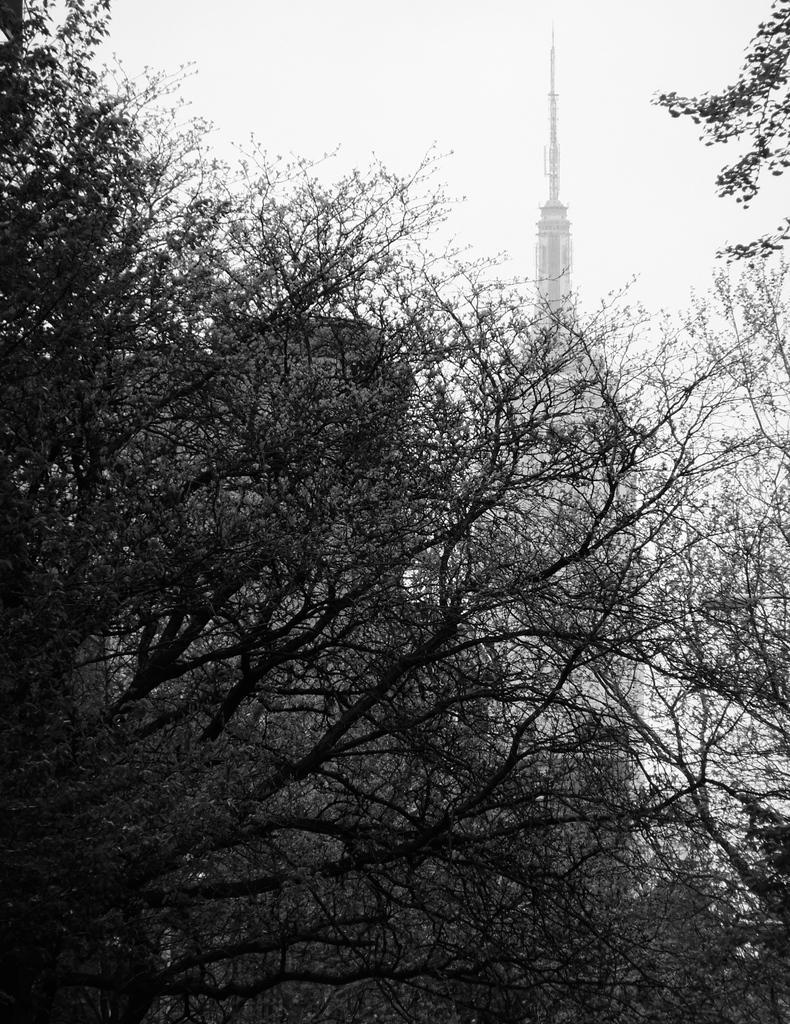In one or two sentences, can you explain what this image depicts? In this image in the foreground there are some trees and in the background there are skyscrapers and buildings on the top of the image there is sky. 